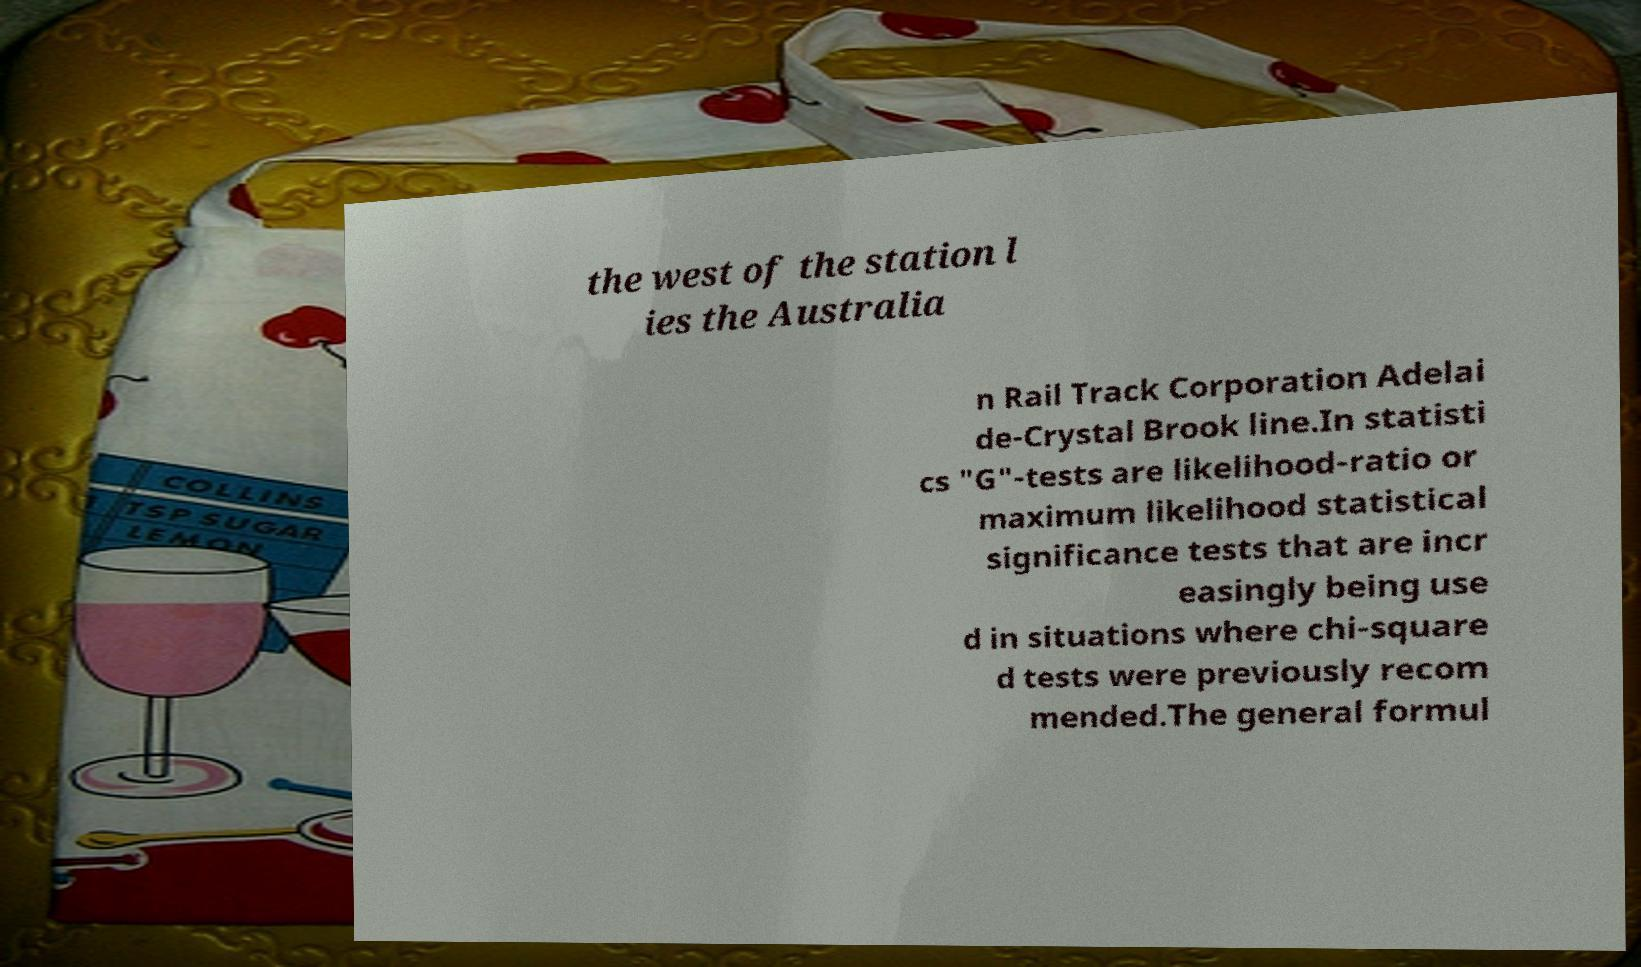I need the written content from this picture converted into text. Can you do that? the west of the station l ies the Australia n Rail Track Corporation Adelai de-Crystal Brook line.In statisti cs "G"-tests are likelihood-ratio or maximum likelihood statistical significance tests that are incr easingly being use d in situations where chi-square d tests were previously recom mended.The general formul 